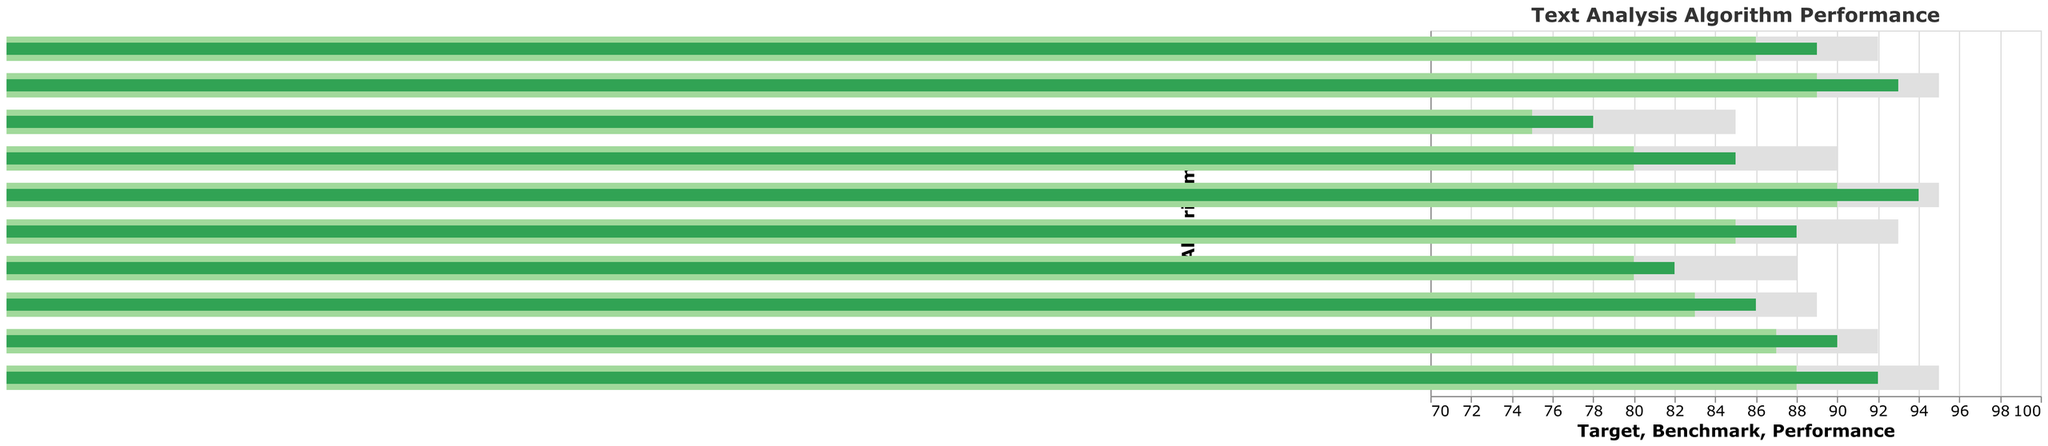What's the title of the chart? The title of the chart is located at the top and it clearly states the purpose of the chart.
Answer: Text Analysis Algorithm Performance How many different algorithms are represented in the chart? By counting the number of bars on the chart, we can see that there are different algorithms displayed.
Answer: 10 Which algorithm has the highest performance relative to its benchmark? Looking at the data entries, you can compare the performance value against the benchmark for each algorithm and identify the one with the largest difference.
Answer: Flair Named Entity Recognition What is the performance of the Gensim LDA algorithm? Referring to the Gensim LDA bar, the performance value is displayed on the bar.
Answer: 78 Which algorithm has the closest performance value to its target? By checking the performance and target values for each algorithm, identify which one has the smallest difference between its performance and target.
Answer: Polyglot Language Detection What is the average performance of all the algorithms? Calculate the sum of all performance values and divide by the number of algorithms: (85 + 92 + 88 + 78 + 82 + 90 + 86 + 94 + 89 + 93) / 10 = 877 / 10 = 87.7
Answer: 87.7 Is there any algorithm that meets or exceeds its target? Compare the performance value with the target value for each algorithm to see if any achieves this benchmark.
Answer: No Which algorithm's performance is above its benchmark but below its target? Compare each algorithm’s performance with its benchmark and its target, filtering for those whose performance is between the two values.
Answer: NLTK Tokenizer, spaCy NER, Stanford CoreNLP POS Tagger, Gensim LDA, TextBlob Sentiment Analysis, fastText Classification, WordNet Lemmatizer, AllenNLP SRL How does the performance of the fastText Classification algorithm compare to the WordNet Lemmatizer? Compare the performance values of the fastText Classification and WordNet Lemmatizer algorithms as displayed by the bars.
Answer: fastText Classification is higher (90 vs 86) What is the difference between the target and the benchmark for the spaCy NER algorithm? Subtract the benchmark value from the target value for spaCy NER: 95 - 88 = 7.
Answer: 7 